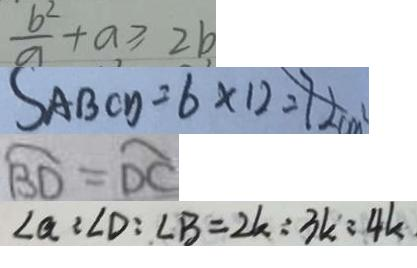Convert formula to latex. <formula><loc_0><loc_0><loc_500><loc_500>\frac { b ^ { 2 } } { a } + a \geq 2 b 
 S _ { A B C D } = 6 \times 1 2 = 7 2 c m ^ { 2 } 
 \widehat { B D } = \widehat { D C } 
 \angle a = \angle D : \angle B = 2 k : 3 k : 4 k</formula> 